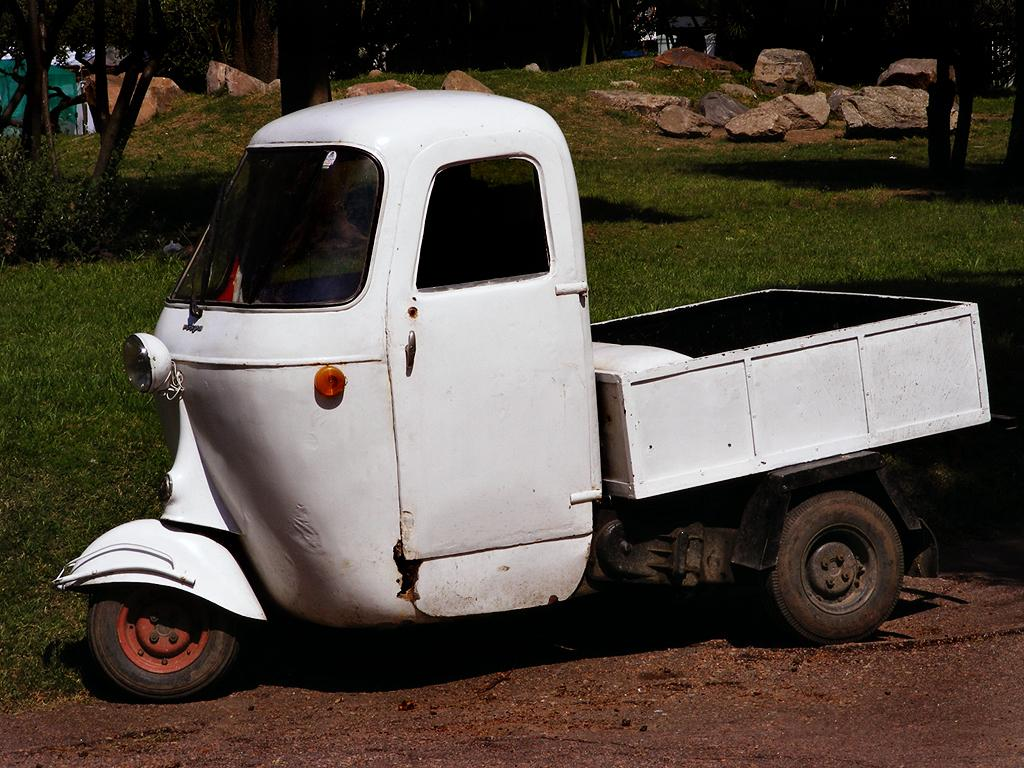What type of vehicle is in the picture? There is an auto trolley in the picture. What color is the auto trolley? The auto trolley is white in color. What is the ground surface like in the image? There is a grass surface in the image. What types of vegetation can be seen on the grass surface? There are plants and trees on the grass surface. Where are the scissors located in the image? There are no scissors present in the image. What type of drum can be seen being played in the image? There is no drum or any musical instrument being played in the image. 